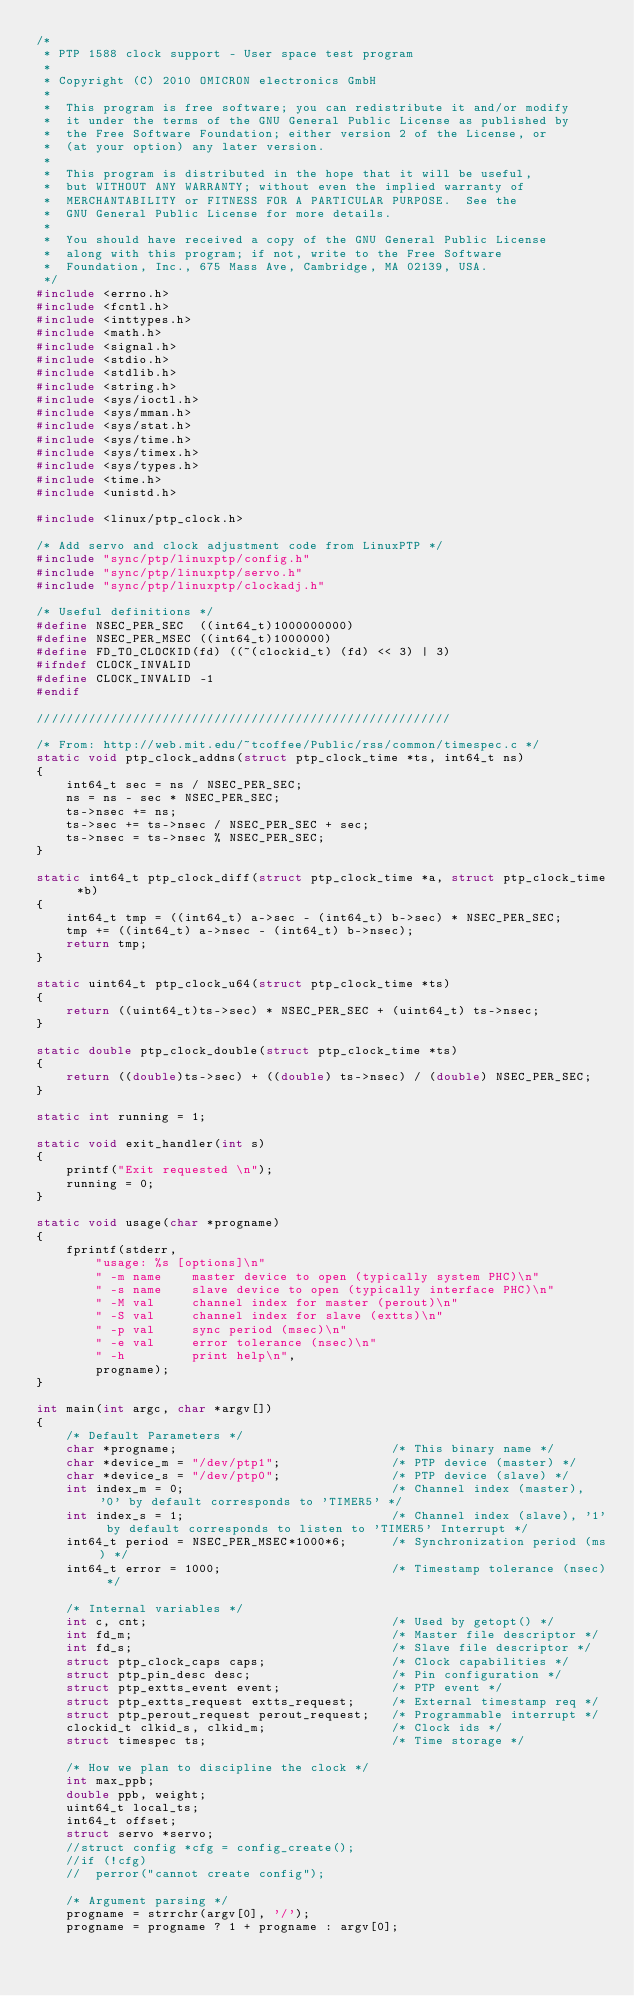Convert code to text. <code><loc_0><loc_0><loc_500><loc_500><_C_>/*
 * PTP 1588 clock support - User space test program
 *
 * Copyright (C) 2010 OMICRON electronics GmbH
 *
 *  This program is free software; you can redistribute it and/or modify
 *  it under the terms of the GNU General Public License as published by
 *  the Free Software Foundation; either version 2 of the License, or
 *  (at your option) any later version.
 *
 *  This program is distributed in the hope that it will be useful,
 *  but WITHOUT ANY WARRANTY; without even the implied warranty of
 *  MERCHANTABILITY or FITNESS FOR A PARTICULAR PURPOSE.  See the
 *  GNU General Public License for more details.
 *
 *  You should have received a copy of the GNU General Public License
 *  along with this program; if not, write to the Free Software
 *  Foundation, Inc., 675 Mass Ave, Cambridge, MA 02139, USA.
 */
#include <errno.h>
#include <fcntl.h>
#include <inttypes.h>
#include <math.h>
#include <signal.h>
#include <stdio.h>
#include <stdlib.h>
#include <string.h>
#include <sys/ioctl.h>
#include <sys/mman.h>
#include <sys/stat.h>
#include <sys/time.h>
#include <sys/timex.h>
#include <sys/types.h>
#include <time.h>
#include <unistd.h>

#include <linux/ptp_clock.h>

/* Add servo and clock adjustment code from LinuxPTP */
#include "sync/ptp/linuxptp/config.h"
#include "sync/ptp/linuxptp/servo.h"
#include "sync/ptp/linuxptp/clockadj.h"

/* Useful definitions */
#define NSEC_PER_SEC  ((int64_t)1000000000)
#define NSEC_PER_MSEC ((int64_t)1000000)
#define FD_TO_CLOCKID(fd) ((~(clockid_t) (fd) << 3) | 3)
#ifndef CLOCK_INVALID
#define CLOCK_INVALID -1
#endif

////////////////////////////////////////////////////////

/* From: http://web.mit.edu/~tcoffee/Public/rss/common/timespec.c */
static void ptp_clock_addns(struct ptp_clock_time *ts, int64_t ns)
{
	int64_t sec = ns / NSEC_PER_SEC;
	ns = ns - sec * NSEC_PER_SEC;
	ts->nsec += ns;
	ts->sec += ts->nsec / NSEC_PER_SEC + sec;
	ts->nsec = ts->nsec % NSEC_PER_SEC;
}

static int64_t ptp_clock_diff(struct ptp_clock_time *a, struct ptp_clock_time *b)
{
	int64_t tmp = ((int64_t) a->sec - (int64_t) b->sec) * NSEC_PER_SEC;
	tmp += ((int64_t) a->nsec - (int64_t) b->nsec);
	return tmp;
}

static uint64_t ptp_clock_u64(struct ptp_clock_time *ts)
{
	return ((uint64_t)ts->sec) * NSEC_PER_SEC + (uint64_t) ts->nsec;
}

static double ptp_clock_double(struct ptp_clock_time *ts)
{
	return ((double)ts->sec) + ((double) ts->nsec) / (double) NSEC_PER_SEC;
}

static int running = 1;

static void exit_handler(int s)
{
	printf("Exit requested \n");
  	running = 0;
}

static void usage(char *progname)
{
	fprintf(stderr,
		"usage: %s [options]\n"
		" -m name    master device to open (typically system PHC)\n"
		" -s name    slave device to open (typically interface PHC)\n"
		" -M val     channel index for master (perout)\n"
		" -S val     channel index for slave (extts)\n"
		" -p val     sync period (msec)\n"
		" -e val     error tolerance (nsec)\n"
		" -h         print help\n",
		progname);
}

int main(int argc, char *argv[])
{
	/* Default Parameters */
	char *progname;								/* This binary name */
	char *device_m = "/dev/ptp1";				/* PTP device (master) */
	char *device_s = "/dev/ptp0";				/* PTP device (slave) */
	int index_m = 0;							/* Channel index (master), '0' by default corresponds to 'TIMER5' */
	int index_s = 1;							/* Channel index (slave), '1' by default corresponds to listen to 'TIMER5' Interrupt */
	int64_t period = NSEC_PER_MSEC*1000*6;		/* Synchronization period (ms) */
	int64_t error = 1000;						/* Timestamp tolerance (nsec) */

	/* Internal variables */
	int c, cnt;									/* Used by getopt() */
	int fd_m;									/* Master file descriptor */
	int fd_s;									/* Slave file descriptor */
	struct ptp_clock_caps caps;					/* Clock capabilities */
	struct ptp_pin_desc desc;					/* Pin configuration */
	struct ptp_extts_event event;				/* PTP event */
	struct ptp_extts_request extts_request;		/* External timestamp req */
	struct ptp_perout_request perout_request;	/* Programmable interrupt */
	clockid_t clkid_s, clkid_m;					/* Clock ids */
	struct timespec ts;							/* Time storage */

	/* How we plan to discipline the clock */
	int max_ppb;
	double ppb, weight;
	uint64_t local_ts;
	int64_t offset;
	struct servo *servo;
	//struct config *cfg = config_create();
	//if (!cfg)
	//	perror("cannot create config");

	/* Argument parsing */
	progname = strrchr(argv[0], '/');
	progname = progname ? 1 + progname : argv[0];</code> 